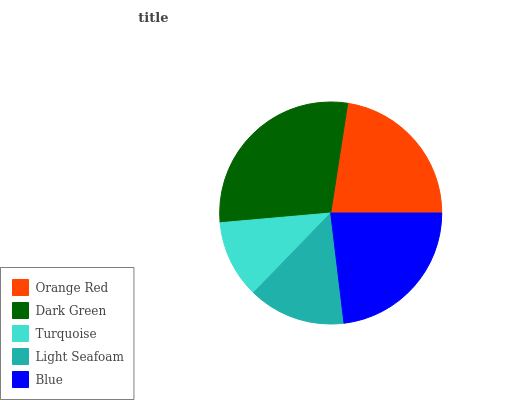Is Turquoise the minimum?
Answer yes or no. Yes. Is Dark Green the maximum?
Answer yes or no. Yes. Is Dark Green the minimum?
Answer yes or no. No. Is Turquoise the maximum?
Answer yes or no. No. Is Dark Green greater than Turquoise?
Answer yes or no. Yes. Is Turquoise less than Dark Green?
Answer yes or no. Yes. Is Turquoise greater than Dark Green?
Answer yes or no. No. Is Dark Green less than Turquoise?
Answer yes or no. No. Is Orange Red the high median?
Answer yes or no. Yes. Is Orange Red the low median?
Answer yes or no. Yes. Is Light Seafoam the high median?
Answer yes or no. No. Is Dark Green the low median?
Answer yes or no. No. 